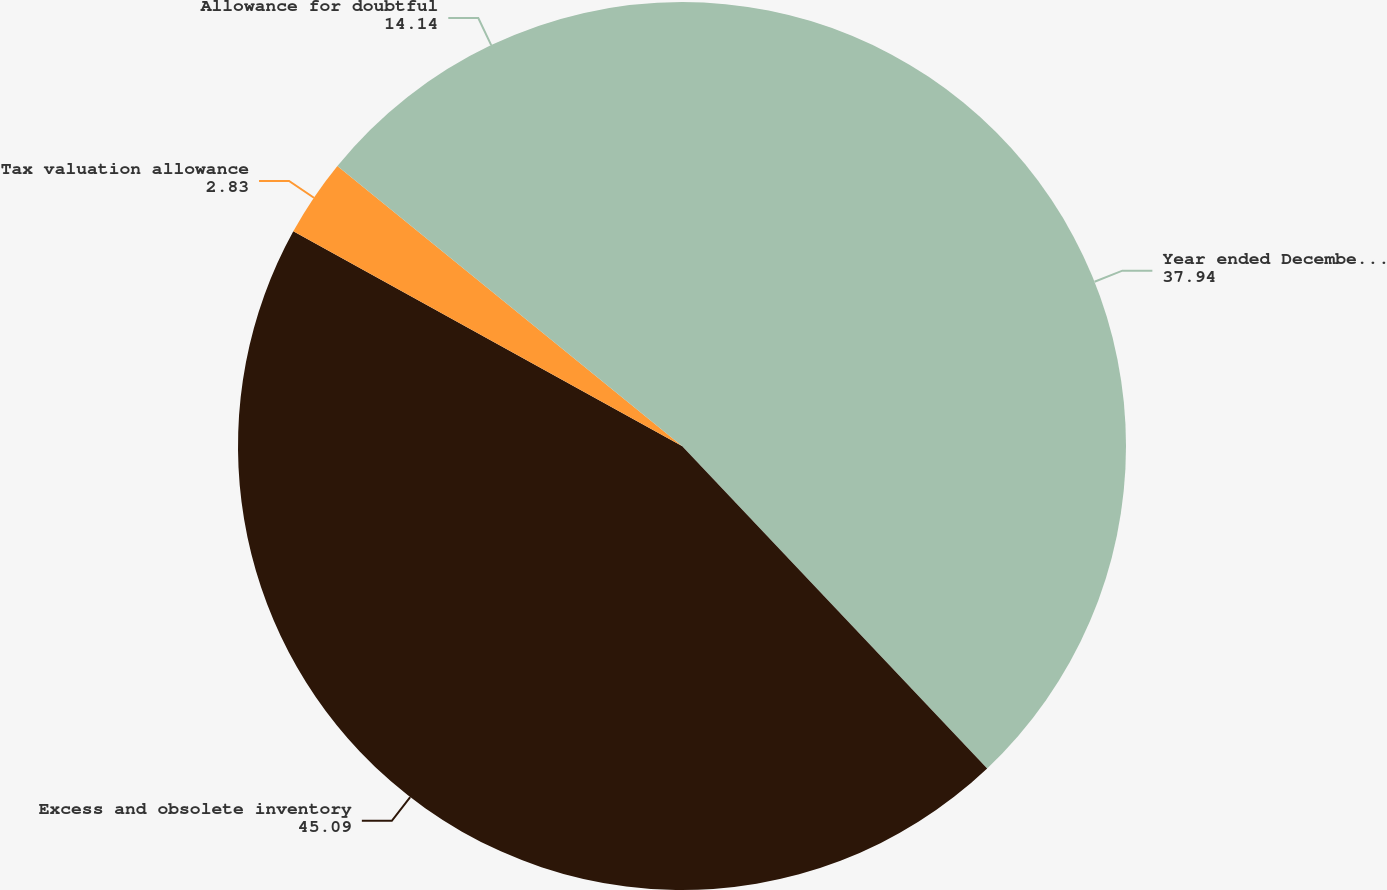<chart> <loc_0><loc_0><loc_500><loc_500><pie_chart><fcel>Year ended December 31 2008<fcel>Excess and obsolete inventory<fcel>Tax valuation allowance<fcel>Allowance for doubtful<nl><fcel>37.94%<fcel>45.09%<fcel>2.83%<fcel>14.14%<nl></chart> 